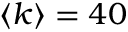Convert formula to latex. <formula><loc_0><loc_0><loc_500><loc_500>\langle k \rangle = 4 0</formula> 